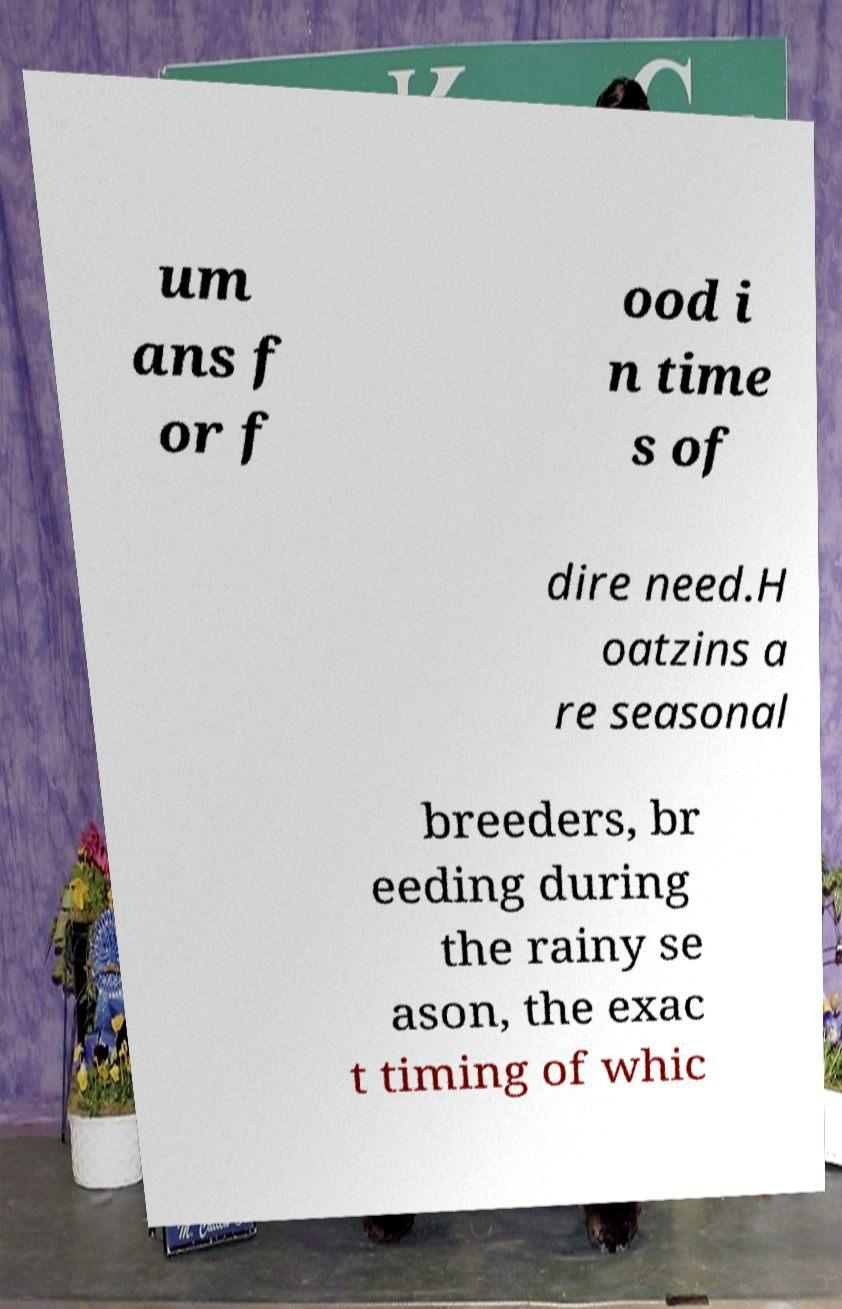There's text embedded in this image that I need extracted. Can you transcribe it verbatim? um ans f or f ood i n time s of dire need.H oatzins a re seasonal breeders, br eeding during the rainy se ason, the exac t timing of whic 